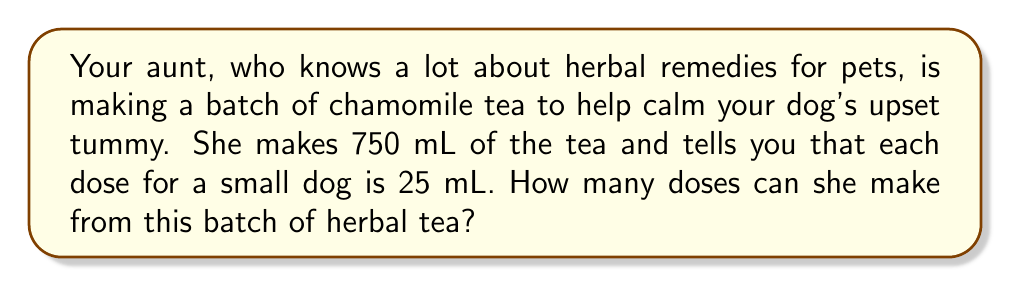Could you help me with this problem? Let's break this down step-by-step:

1. We need to find out how many 25 mL doses are in 750 mL of tea.

2. This is a division problem. We can set it up like this:

   $$ \text{Number of doses} = \frac{\text{Total volume of tea}}{\text{Volume per dose}} $$

3. Let's plug in our numbers:

   $$ \text{Number of doses} = \frac{750 \text{ mL}}{25 \text{ mL}} $$

4. Now we can divide:

   $$ \text{Number of doses} = 30 $$

5. Since we can't have a partial dose, and we're asking how many complete doses can be made, we don't need to round this number.

Therefore, your aunt can make 30 doses from her batch of herbal tea.
Answer: $30$ doses 